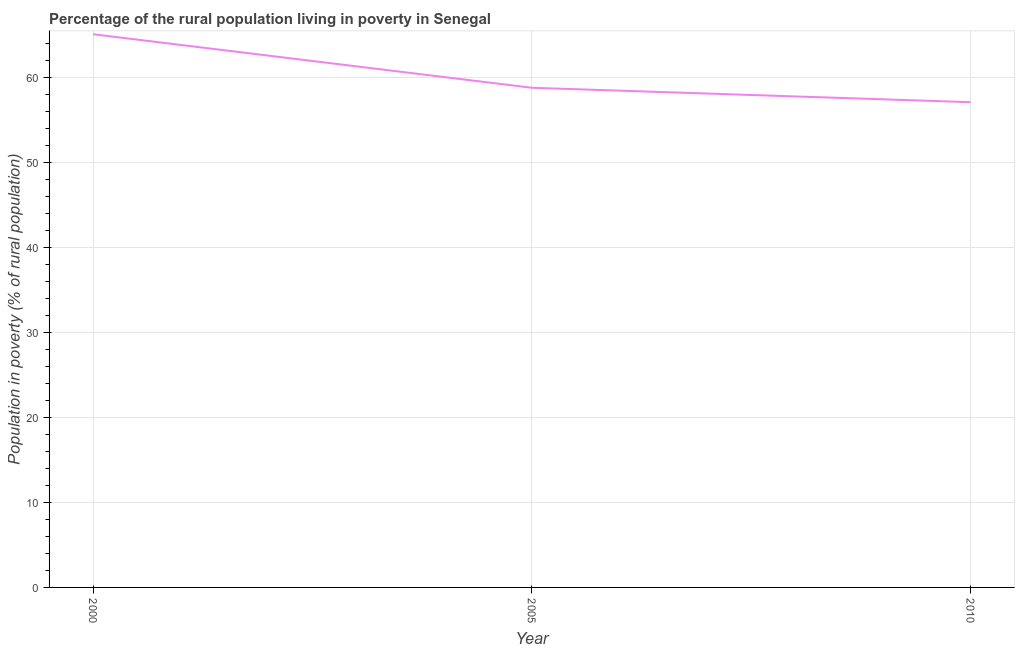What is the percentage of rural population living below poverty line in 2005?
Your response must be concise. 58.8. Across all years, what is the maximum percentage of rural population living below poverty line?
Your answer should be very brief. 65.1. Across all years, what is the minimum percentage of rural population living below poverty line?
Your response must be concise. 57.1. In which year was the percentage of rural population living below poverty line maximum?
Provide a short and direct response. 2000. In which year was the percentage of rural population living below poverty line minimum?
Make the answer very short. 2010. What is the sum of the percentage of rural population living below poverty line?
Ensure brevity in your answer.  181. What is the difference between the percentage of rural population living below poverty line in 2000 and 2005?
Ensure brevity in your answer.  6.3. What is the average percentage of rural population living below poverty line per year?
Keep it short and to the point. 60.33. What is the median percentage of rural population living below poverty line?
Offer a terse response. 58.8. What is the ratio of the percentage of rural population living below poverty line in 2000 to that in 2010?
Make the answer very short. 1.14. What is the difference between the highest and the second highest percentage of rural population living below poverty line?
Your answer should be very brief. 6.3. Is the sum of the percentage of rural population living below poverty line in 2005 and 2010 greater than the maximum percentage of rural population living below poverty line across all years?
Ensure brevity in your answer.  Yes. What is the difference between the highest and the lowest percentage of rural population living below poverty line?
Make the answer very short. 8. Does the percentage of rural population living below poverty line monotonically increase over the years?
Provide a succinct answer. No. How many lines are there?
Make the answer very short. 1. What is the difference between two consecutive major ticks on the Y-axis?
Offer a very short reply. 10. Are the values on the major ticks of Y-axis written in scientific E-notation?
Provide a succinct answer. No. What is the title of the graph?
Give a very brief answer. Percentage of the rural population living in poverty in Senegal. What is the label or title of the Y-axis?
Ensure brevity in your answer.  Population in poverty (% of rural population). What is the Population in poverty (% of rural population) of 2000?
Ensure brevity in your answer.  65.1. What is the Population in poverty (% of rural population) of 2005?
Your answer should be compact. 58.8. What is the Population in poverty (% of rural population) of 2010?
Make the answer very short. 57.1. What is the difference between the Population in poverty (% of rural population) in 2000 and 2005?
Provide a short and direct response. 6.3. What is the difference between the Population in poverty (% of rural population) in 2000 and 2010?
Make the answer very short. 8. What is the ratio of the Population in poverty (% of rural population) in 2000 to that in 2005?
Your answer should be compact. 1.11. What is the ratio of the Population in poverty (% of rural population) in 2000 to that in 2010?
Provide a succinct answer. 1.14. What is the ratio of the Population in poverty (% of rural population) in 2005 to that in 2010?
Offer a very short reply. 1.03. 